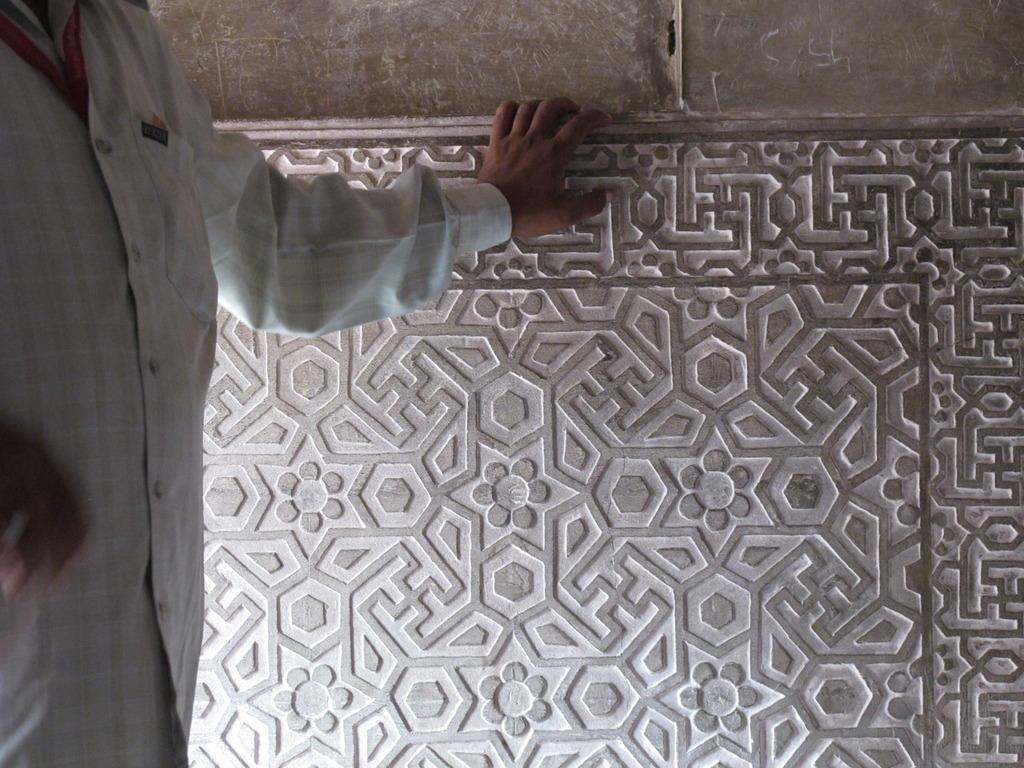In one or two sentences, can you explain what this image depicts? In this image we can see one big wall with a design, one person with red tag standing and holding the wall. 